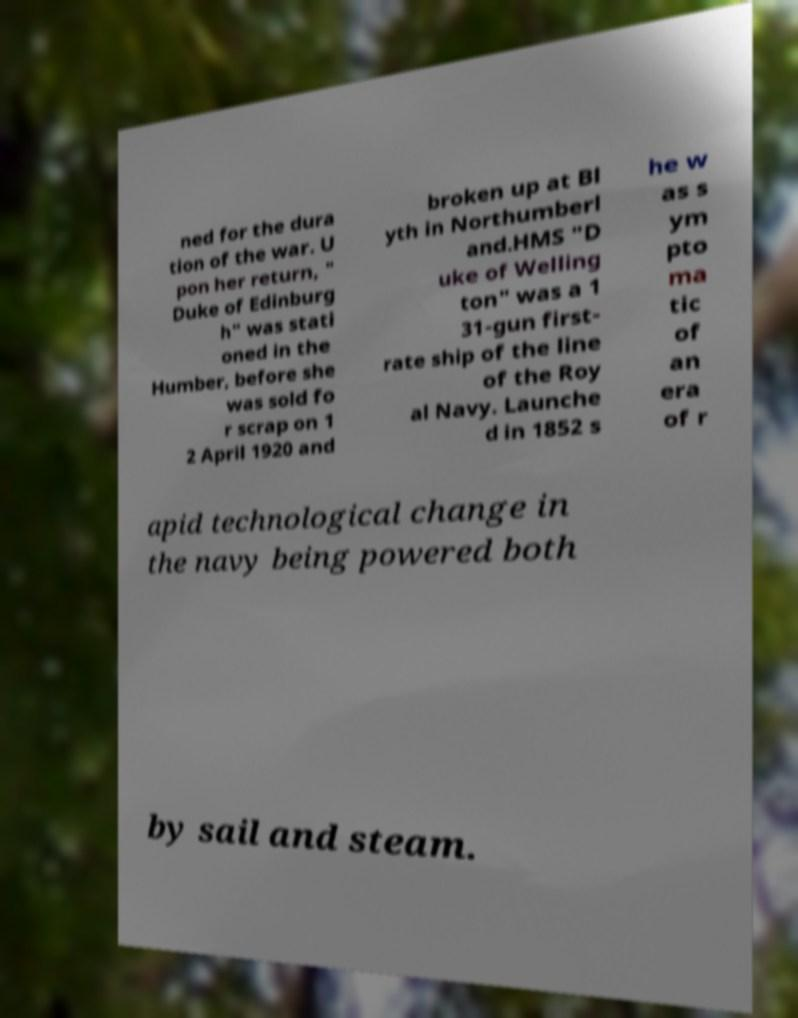There's text embedded in this image that I need extracted. Can you transcribe it verbatim? ned for the dura tion of the war. U pon her return, " Duke of Edinburg h" was stati oned in the Humber, before she was sold fo r scrap on 1 2 April 1920 and broken up at Bl yth in Northumberl and.HMS "D uke of Welling ton" was a 1 31-gun first- rate ship of the line of the Roy al Navy. Launche d in 1852 s he w as s ym pto ma tic of an era of r apid technological change in the navy being powered both by sail and steam. 